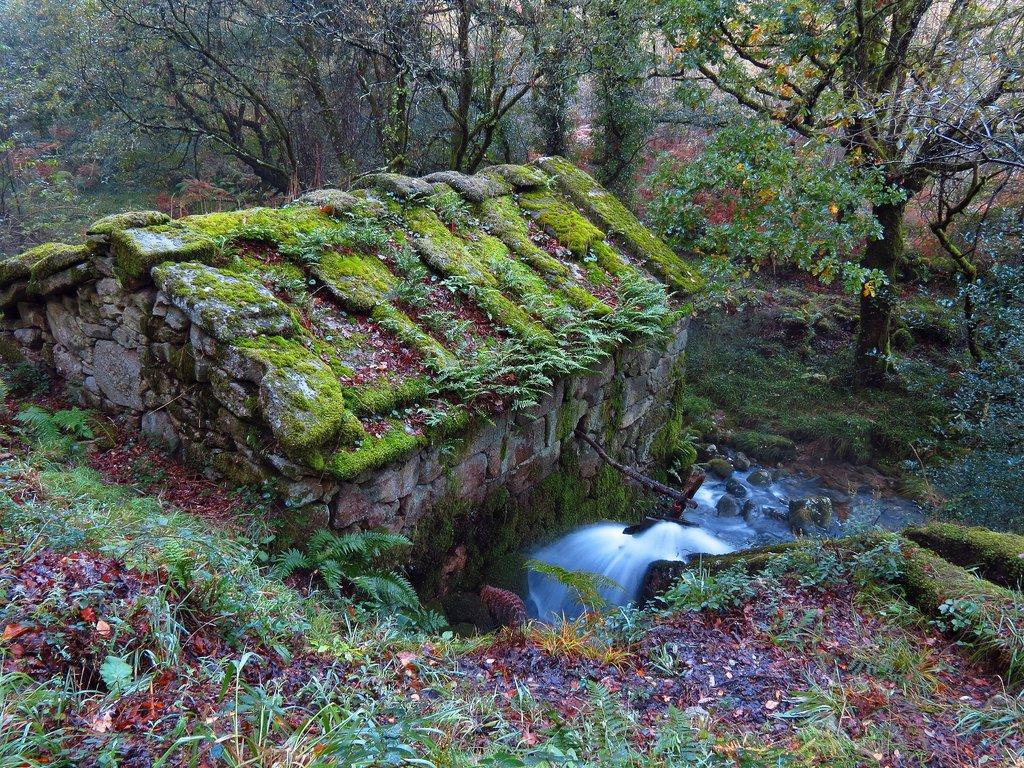What type of vegetation can be seen in the image? There is grass in the image. What color is the grass? The grass is green. What other type of vegetation is present in the image? There are trees in the image. What color are the trees? The trees are green. What natural element can be observed in the image? There is water flowing in the image. Can you see an aunt holding a match and a knife in the image? There is no person, match, or knife present in the image. 